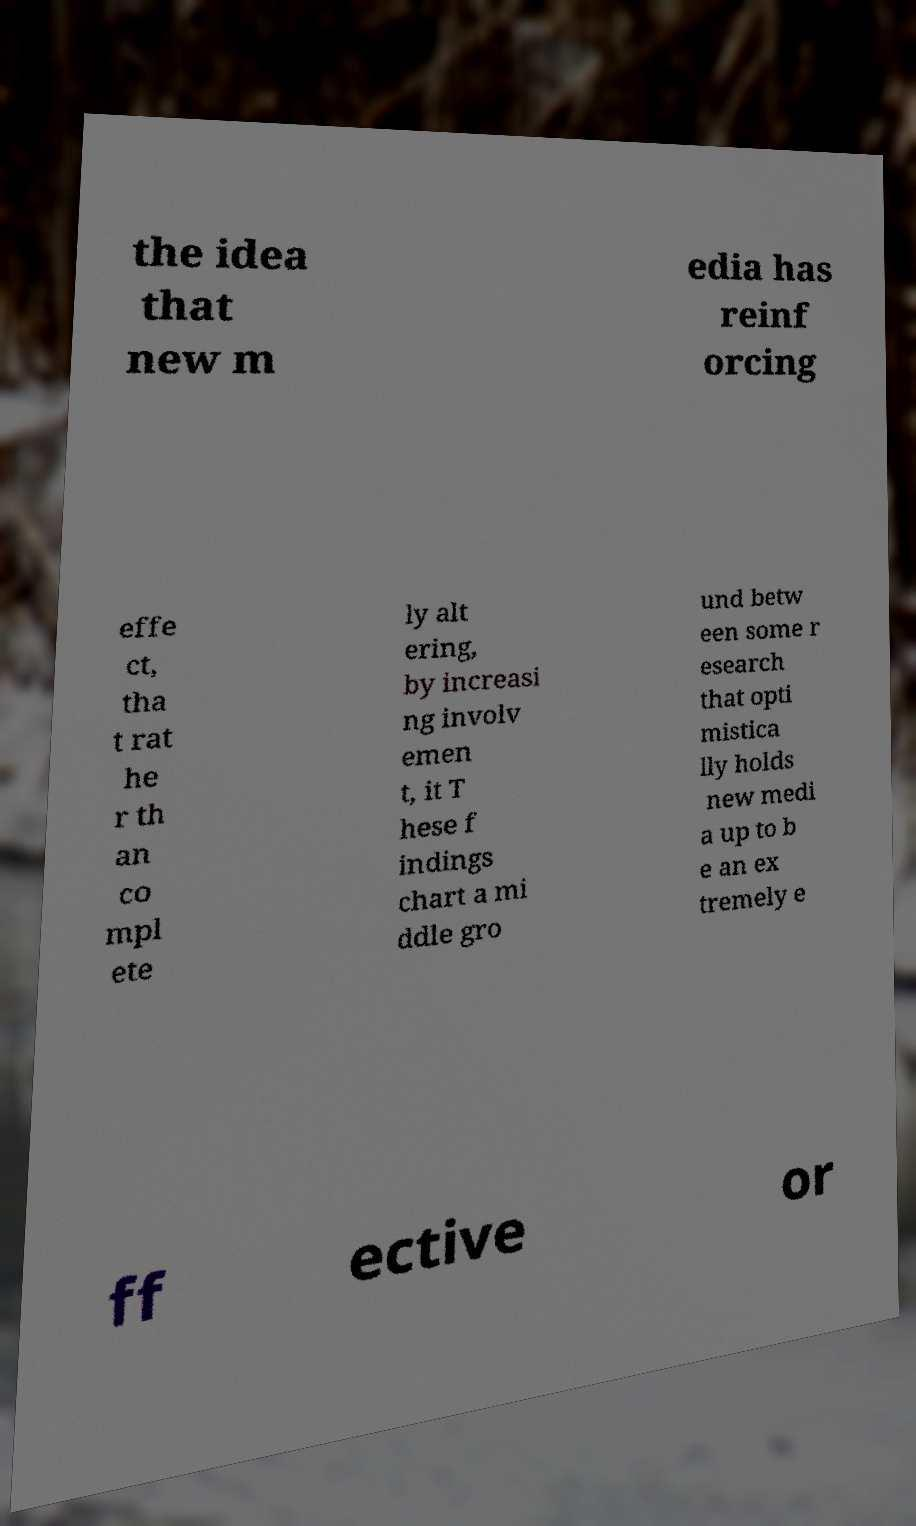For documentation purposes, I need the text within this image transcribed. Could you provide that? the idea that new m edia has reinf orcing effe ct, tha t rat he r th an co mpl ete ly alt ering, by increasi ng involv emen t, it T hese f indings chart a mi ddle gro und betw een some r esearch that opti mistica lly holds new medi a up to b e an ex tremely e ff ective or 